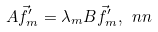<formula> <loc_0><loc_0><loc_500><loc_500>A \vec { f } ^ { \prime } _ { m } = \lambda _ { m } B \vec { f } ^ { \prime } _ { m } , \ n n</formula> 